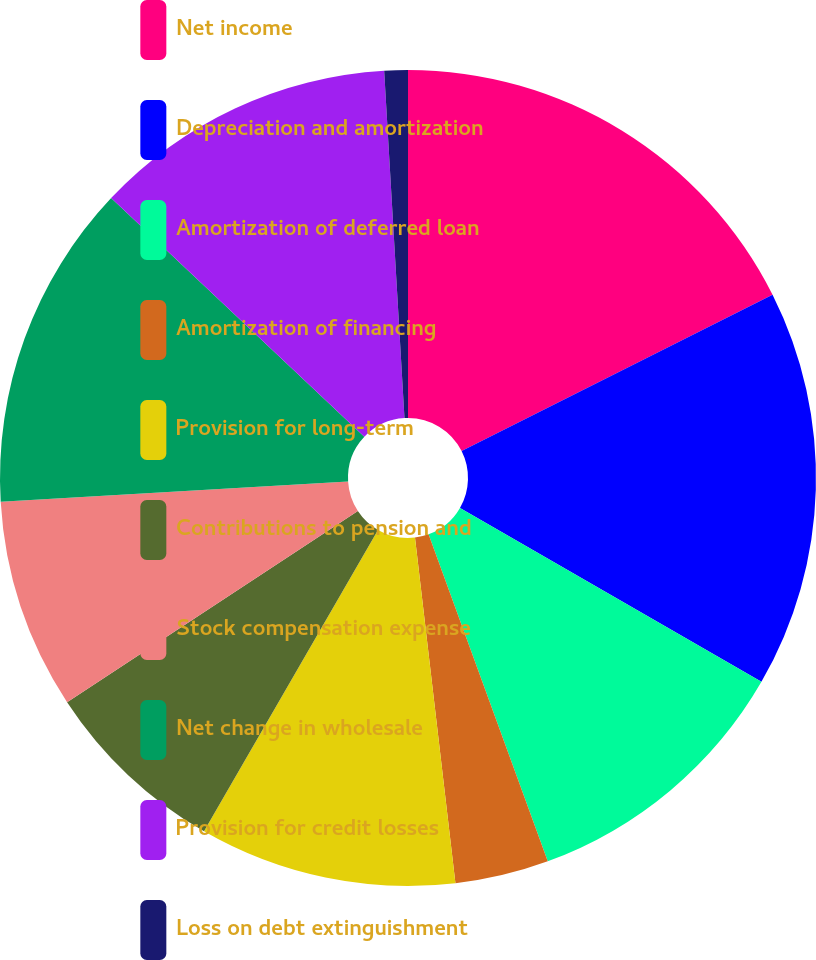Convert chart to OTSL. <chart><loc_0><loc_0><loc_500><loc_500><pie_chart><fcel>Net income<fcel>Depreciation and amortization<fcel>Amortization of deferred loan<fcel>Amortization of financing<fcel>Provision for long-term<fcel>Contributions to pension and<fcel>Stock compensation expense<fcel>Net change in wholesale<fcel>Provision for credit losses<fcel>Loss on debt extinguishment<nl><fcel>17.59%<fcel>15.74%<fcel>11.11%<fcel>3.71%<fcel>10.19%<fcel>7.41%<fcel>8.33%<fcel>12.96%<fcel>12.04%<fcel>0.93%<nl></chart> 